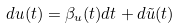Convert formula to latex. <formula><loc_0><loc_0><loc_500><loc_500>d u ( t ) = \beta _ { u } ( t ) d t + d \tilde { u } ( t )</formula> 